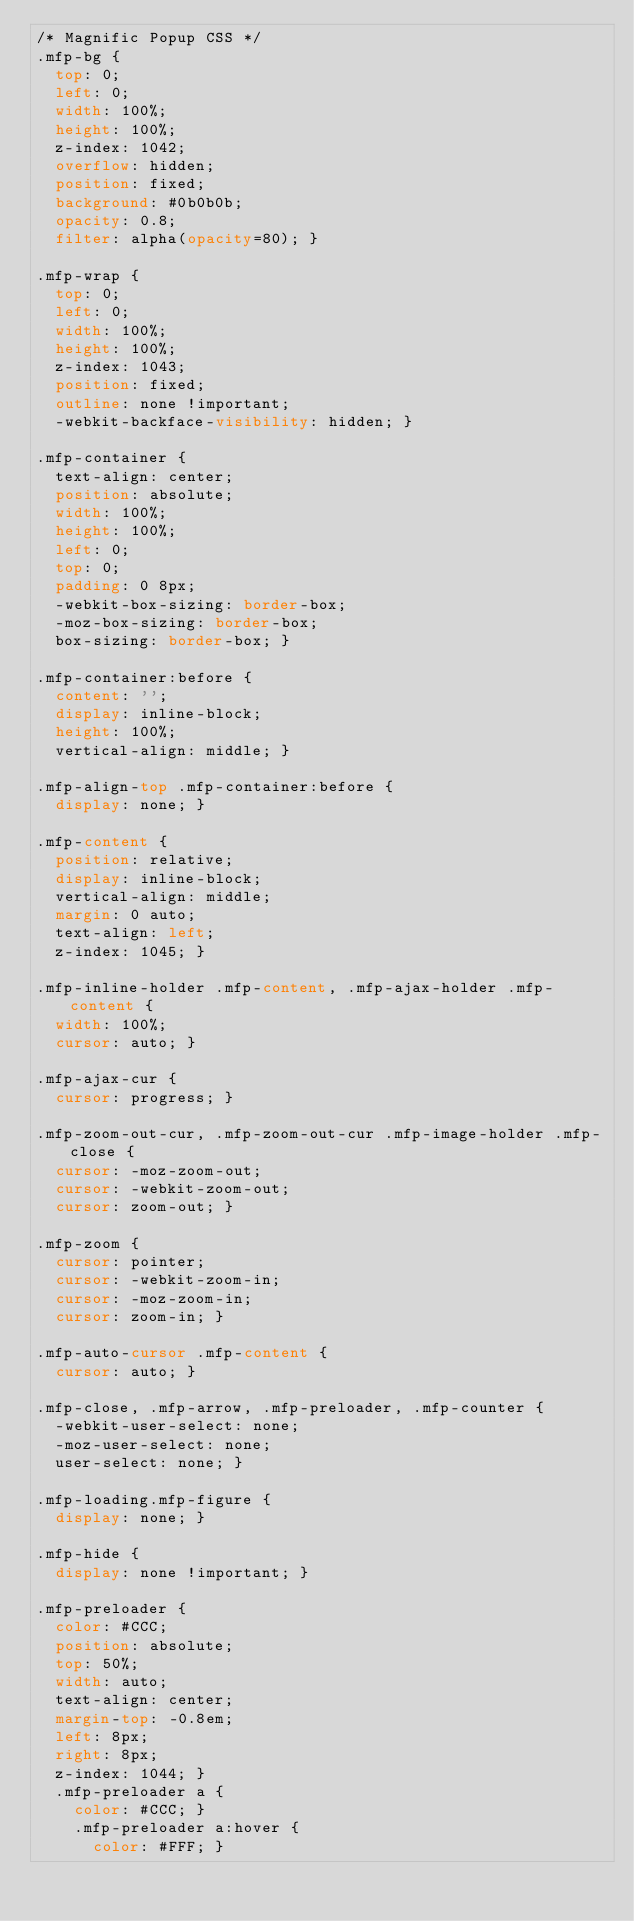<code> <loc_0><loc_0><loc_500><loc_500><_CSS_>/* Magnific Popup CSS */
.mfp-bg {
  top: 0;
  left: 0;
  width: 100%;
  height: 100%;
  z-index: 1042;
  overflow: hidden;
  position: fixed;
  background: #0b0b0b;
  opacity: 0.8;
  filter: alpha(opacity=80); }

.mfp-wrap {
  top: 0;
  left: 0;
  width: 100%;
  height: 100%;
  z-index: 1043;
  position: fixed;
  outline: none !important;
  -webkit-backface-visibility: hidden; }

.mfp-container {
  text-align: center;
  position: absolute;
  width: 100%;
  height: 100%;
  left: 0;
  top: 0;
  padding: 0 8px;
  -webkit-box-sizing: border-box;
  -moz-box-sizing: border-box;
  box-sizing: border-box; }

.mfp-container:before {
  content: '';
  display: inline-block;
  height: 100%;
  vertical-align: middle; }

.mfp-align-top .mfp-container:before {
  display: none; }

.mfp-content {
  position: relative;
  display: inline-block;
  vertical-align: middle;
  margin: 0 auto;
  text-align: left;
  z-index: 1045; }

.mfp-inline-holder .mfp-content, .mfp-ajax-holder .mfp-content {
  width: 100%;
  cursor: auto; }

.mfp-ajax-cur {
  cursor: progress; }

.mfp-zoom-out-cur, .mfp-zoom-out-cur .mfp-image-holder .mfp-close {
  cursor: -moz-zoom-out;
  cursor: -webkit-zoom-out;
  cursor: zoom-out; }

.mfp-zoom {
  cursor: pointer;
  cursor: -webkit-zoom-in;
  cursor: -moz-zoom-in;
  cursor: zoom-in; }

.mfp-auto-cursor .mfp-content {
  cursor: auto; }

.mfp-close, .mfp-arrow, .mfp-preloader, .mfp-counter {
  -webkit-user-select: none;
  -moz-user-select: none;
  user-select: none; }

.mfp-loading.mfp-figure {
  display: none; }

.mfp-hide {
  display: none !important; }

.mfp-preloader {
  color: #CCC;
  position: absolute;
  top: 50%;
  width: auto;
  text-align: center;
  margin-top: -0.8em;
  left: 8px;
  right: 8px;
  z-index: 1044; }
  .mfp-preloader a {
    color: #CCC; }
    .mfp-preloader a:hover {
      color: #FFF; }
</code> 